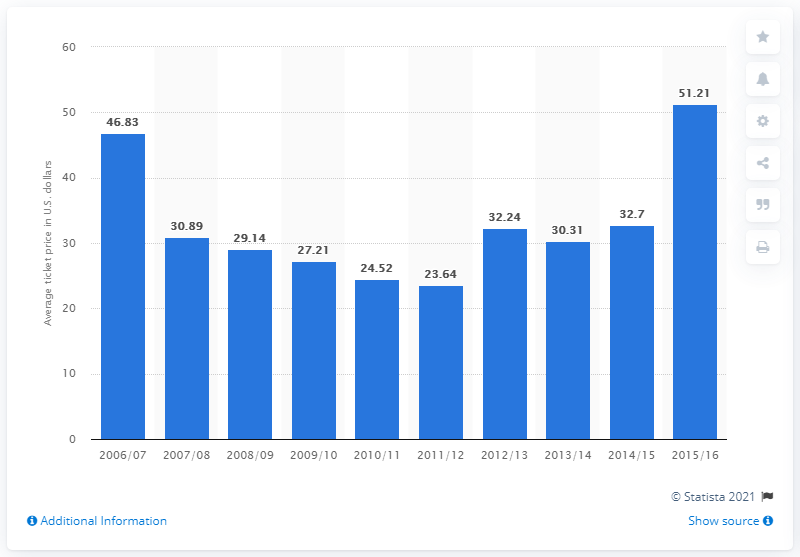Give some essential details in this illustration. The average ticket price for Washington Wizards games in the 2006/2007 season was $46.83. 